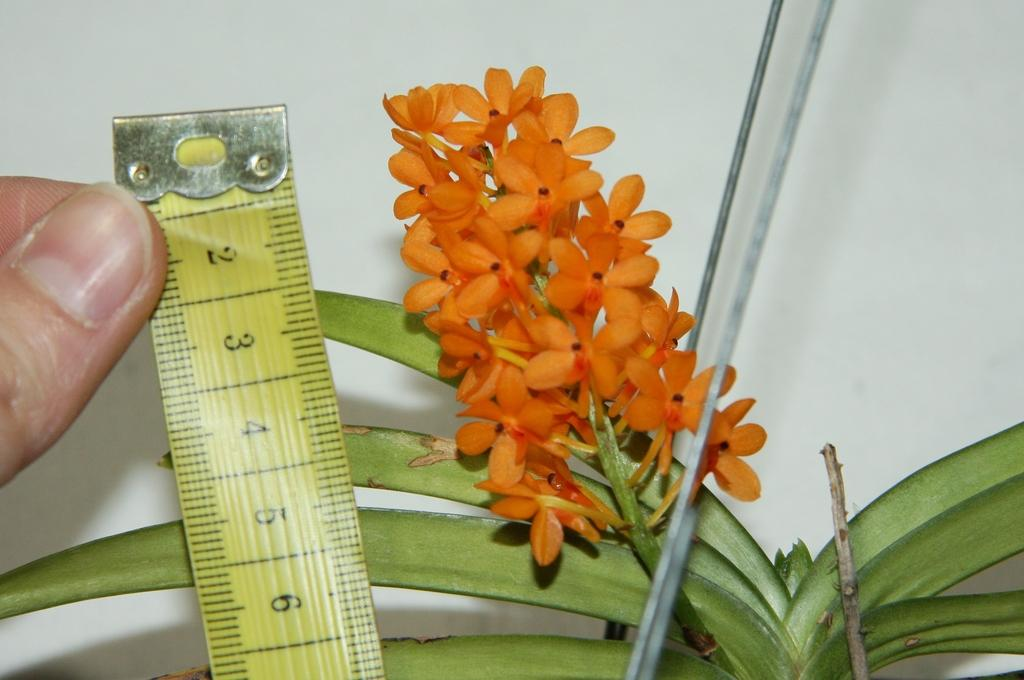What is the main subject of the image? There is a person in the image. What is the person holding in the image? The person is holding a tape. What type of flowers can be seen in the image? There are orange color flowers on a plant. What can be seen in the background of the image? There is a wall in the background of the image. What disease is the person in the image suffering from? There is no indication in the image that the person is suffering from any disease. Who is the father of the person in the image? The image does not provide any information about the person's father. 